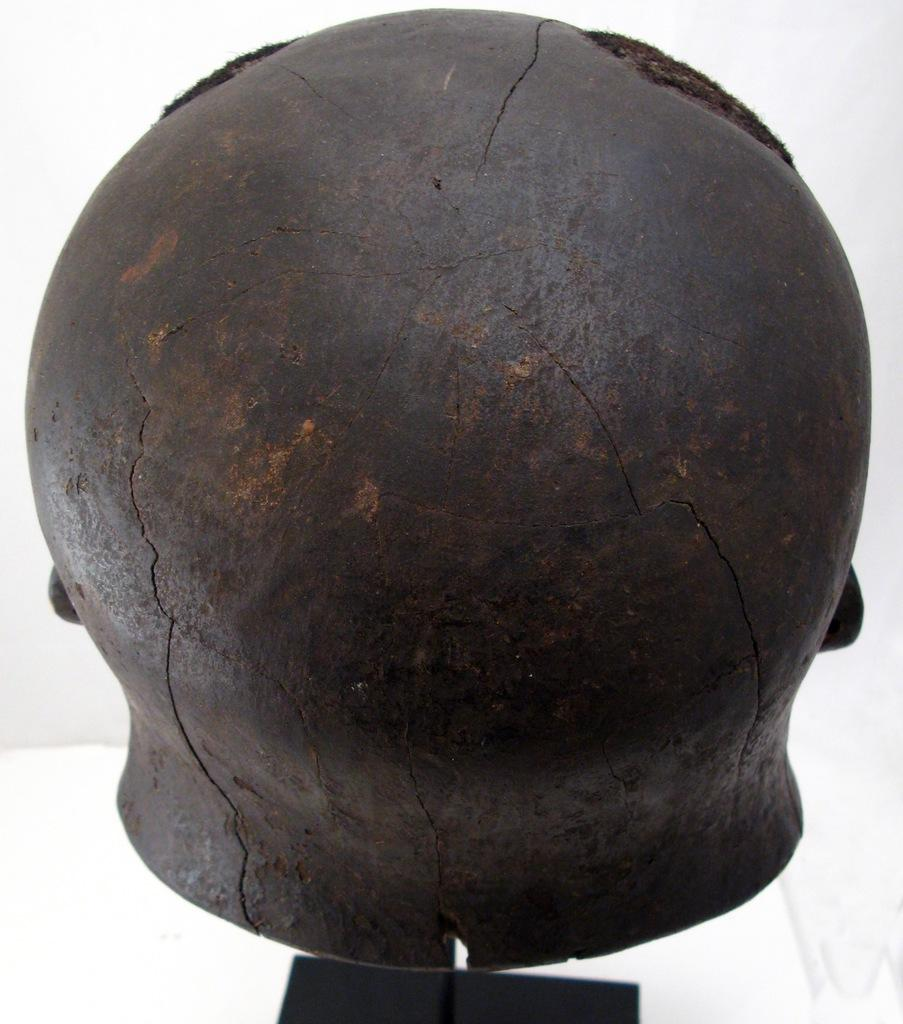What is the color of the main object in the image? The main object in the image is black in color. What is the color of the background in the image? The background of the image is white in color. How many sheep can be seen grazing in the image? There are no sheep present in the image. What type of vegetable is being used to control the object in the image? There is no vegetable or control mechanism present in the image. 